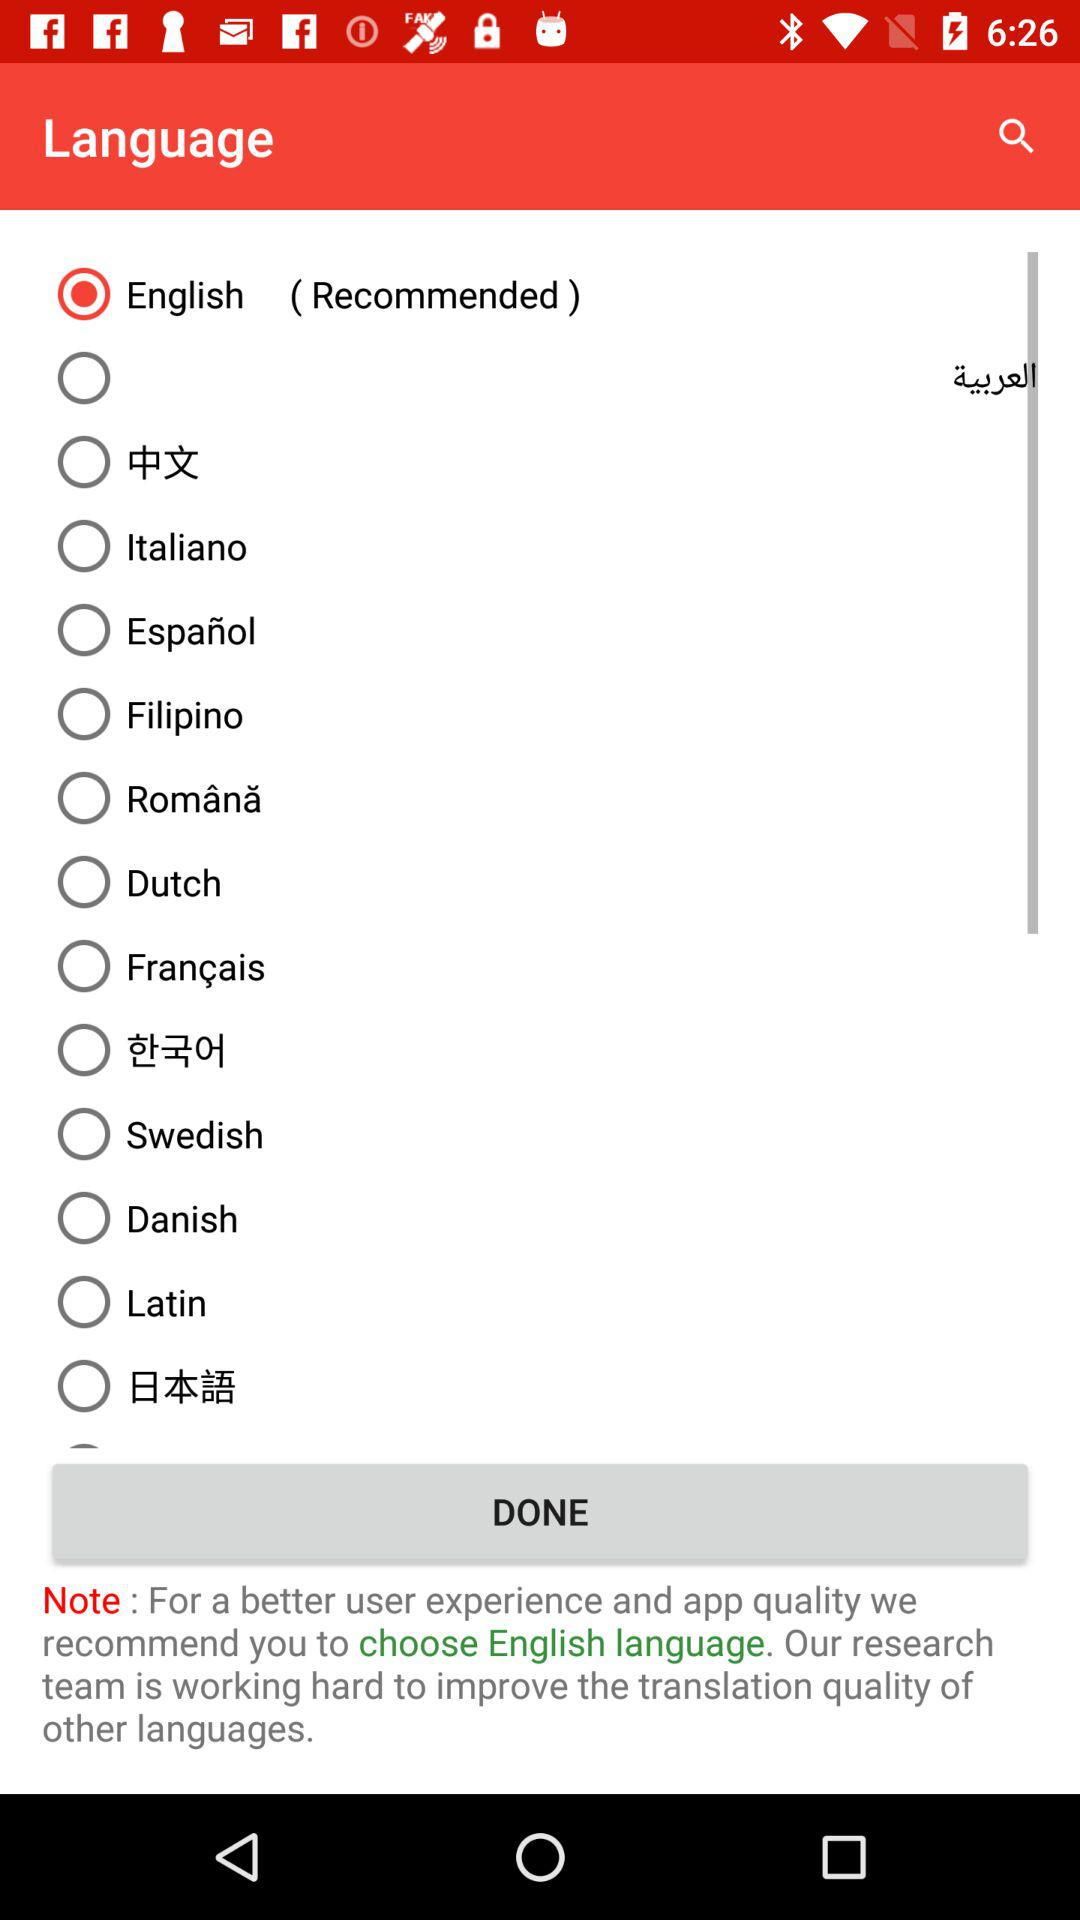How many languages does the user have the option to choose from?
Answer the question using a single word or phrase. 14 